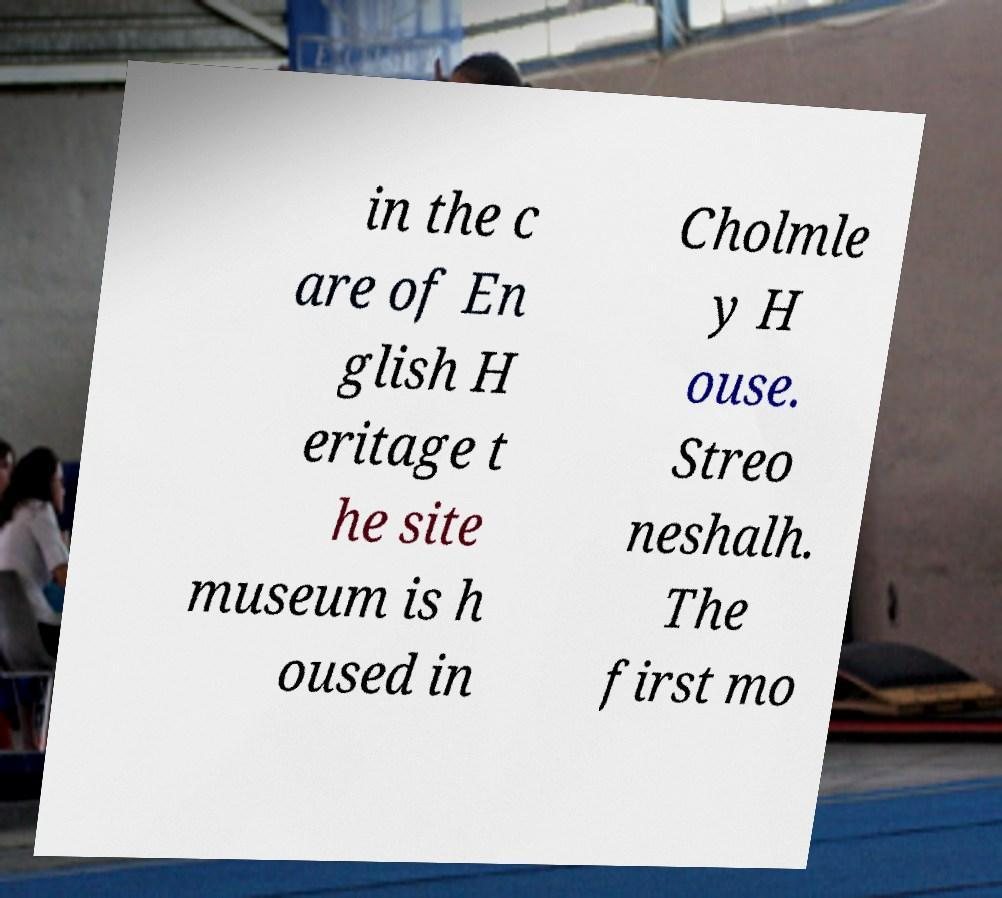Could you assist in decoding the text presented in this image and type it out clearly? in the c are of En glish H eritage t he site museum is h oused in Cholmle y H ouse. Streo neshalh. The first mo 